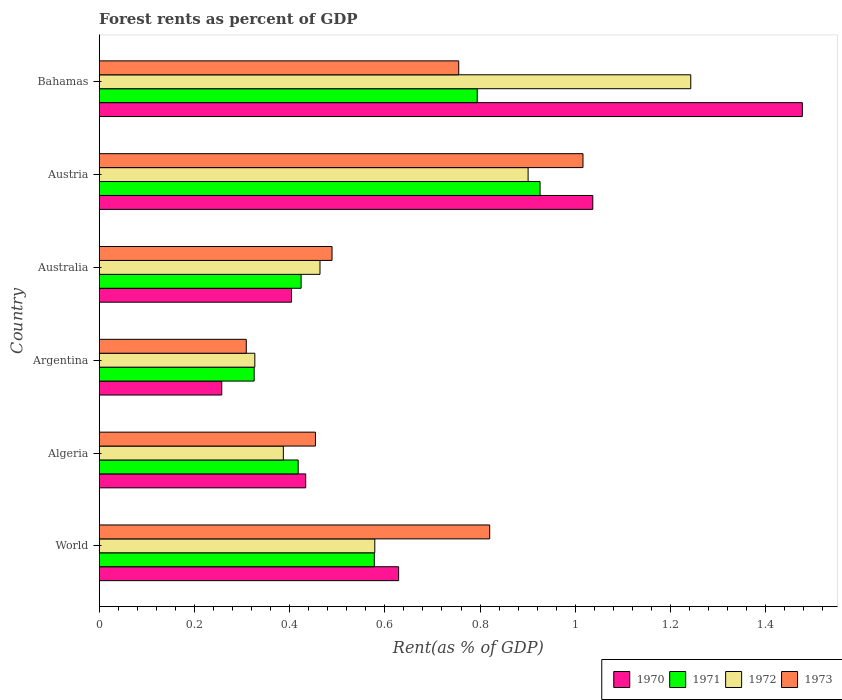How many groups of bars are there?
Keep it short and to the point. 6. Are the number of bars per tick equal to the number of legend labels?
Offer a very short reply. Yes. Are the number of bars on each tick of the Y-axis equal?
Offer a terse response. Yes. What is the label of the 5th group of bars from the top?
Provide a succinct answer. Algeria. In how many cases, is the number of bars for a given country not equal to the number of legend labels?
Offer a terse response. 0. What is the forest rent in 1973 in Bahamas?
Your response must be concise. 0.76. Across all countries, what is the maximum forest rent in 1972?
Make the answer very short. 1.24. Across all countries, what is the minimum forest rent in 1973?
Provide a succinct answer. 0.31. In which country was the forest rent in 1972 maximum?
Provide a short and direct response. Bahamas. What is the total forest rent in 1972 in the graph?
Ensure brevity in your answer.  3.9. What is the difference between the forest rent in 1972 in Australia and that in World?
Ensure brevity in your answer.  -0.12. What is the difference between the forest rent in 1972 in World and the forest rent in 1971 in Algeria?
Offer a terse response. 0.16. What is the average forest rent in 1971 per country?
Offer a terse response. 0.58. What is the difference between the forest rent in 1971 and forest rent in 1970 in Bahamas?
Your response must be concise. -0.68. In how many countries, is the forest rent in 1973 greater than 0.8 %?
Your answer should be compact. 2. What is the ratio of the forest rent in 1971 in Austria to that in Bahamas?
Provide a succinct answer. 1.17. Is the forest rent in 1973 in Argentina less than that in Bahamas?
Provide a succinct answer. Yes. Is the difference between the forest rent in 1971 in Bahamas and World greater than the difference between the forest rent in 1970 in Bahamas and World?
Keep it short and to the point. No. What is the difference between the highest and the second highest forest rent in 1971?
Make the answer very short. 0.13. What is the difference between the highest and the lowest forest rent in 1972?
Your answer should be very brief. 0.92. Is the sum of the forest rent in 1970 in Austria and Bahamas greater than the maximum forest rent in 1972 across all countries?
Give a very brief answer. Yes. Is it the case that in every country, the sum of the forest rent in 1970 and forest rent in 1971 is greater than the sum of forest rent in 1973 and forest rent in 1972?
Provide a succinct answer. No. How many bars are there?
Give a very brief answer. 24. What is the difference between two consecutive major ticks on the X-axis?
Give a very brief answer. 0.2. Are the values on the major ticks of X-axis written in scientific E-notation?
Provide a succinct answer. No. Does the graph contain any zero values?
Make the answer very short. No. Does the graph contain grids?
Offer a very short reply. No. What is the title of the graph?
Give a very brief answer. Forest rents as percent of GDP. Does "1982" appear as one of the legend labels in the graph?
Provide a succinct answer. No. What is the label or title of the X-axis?
Ensure brevity in your answer.  Rent(as % of GDP). What is the Rent(as % of GDP) of 1970 in World?
Your answer should be very brief. 0.63. What is the Rent(as % of GDP) of 1971 in World?
Provide a short and direct response. 0.58. What is the Rent(as % of GDP) of 1972 in World?
Give a very brief answer. 0.58. What is the Rent(as % of GDP) of 1973 in World?
Offer a terse response. 0.82. What is the Rent(as % of GDP) in 1970 in Algeria?
Make the answer very short. 0.43. What is the Rent(as % of GDP) of 1971 in Algeria?
Your answer should be very brief. 0.42. What is the Rent(as % of GDP) in 1972 in Algeria?
Your answer should be very brief. 0.39. What is the Rent(as % of GDP) in 1973 in Algeria?
Offer a terse response. 0.45. What is the Rent(as % of GDP) of 1970 in Argentina?
Provide a succinct answer. 0.26. What is the Rent(as % of GDP) in 1971 in Argentina?
Keep it short and to the point. 0.33. What is the Rent(as % of GDP) of 1972 in Argentina?
Provide a succinct answer. 0.33. What is the Rent(as % of GDP) of 1973 in Argentina?
Keep it short and to the point. 0.31. What is the Rent(as % of GDP) in 1970 in Australia?
Your answer should be very brief. 0.4. What is the Rent(as % of GDP) in 1971 in Australia?
Keep it short and to the point. 0.42. What is the Rent(as % of GDP) in 1972 in Australia?
Ensure brevity in your answer.  0.46. What is the Rent(as % of GDP) of 1973 in Australia?
Provide a short and direct response. 0.49. What is the Rent(as % of GDP) of 1970 in Austria?
Make the answer very short. 1.04. What is the Rent(as % of GDP) of 1971 in Austria?
Give a very brief answer. 0.93. What is the Rent(as % of GDP) in 1972 in Austria?
Give a very brief answer. 0.9. What is the Rent(as % of GDP) in 1973 in Austria?
Provide a succinct answer. 1.02. What is the Rent(as % of GDP) of 1970 in Bahamas?
Provide a short and direct response. 1.48. What is the Rent(as % of GDP) in 1971 in Bahamas?
Make the answer very short. 0.79. What is the Rent(as % of GDP) of 1972 in Bahamas?
Provide a short and direct response. 1.24. What is the Rent(as % of GDP) in 1973 in Bahamas?
Your answer should be very brief. 0.76. Across all countries, what is the maximum Rent(as % of GDP) in 1970?
Provide a short and direct response. 1.48. Across all countries, what is the maximum Rent(as % of GDP) of 1971?
Give a very brief answer. 0.93. Across all countries, what is the maximum Rent(as % of GDP) of 1972?
Your response must be concise. 1.24. Across all countries, what is the maximum Rent(as % of GDP) in 1973?
Provide a succinct answer. 1.02. Across all countries, what is the minimum Rent(as % of GDP) of 1970?
Keep it short and to the point. 0.26. Across all countries, what is the minimum Rent(as % of GDP) in 1971?
Offer a very short reply. 0.33. Across all countries, what is the minimum Rent(as % of GDP) in 1972?
Your response must be concise. 0.33. Across all countries, what is the minimum Rent(as % of GDP) in 1973?
Your response must be concise. 0.31. What is the total Rent(as % of GDP) in 1970 in the graph?
Provide a succinct answer. 4.24. What is the total Rent(as % of GDP) in 1971 in the graph?
Your response must be concise. 3.47. What is the total Rent(as % of GDP) of 1972 in the graph?
Give a very brief answer. 3.9. What is the total Rent(as % of GDP) in 1973 in the graph?
Make the answer very short. 3.84. What is the difference between the Rent(as % of GDP) in 1970 in World and that in Algeria?
Your answer should be compact. 0.2. What is the difference between the Rent(as % of GDP) in 1971 in World and that in Algeria?
Make the answer very short. 0.16. What is the difference between the Rent(as % of GDP) in 1972 in World and that in Algeria?
Your response must be concise. 0.19. What is the difference between the Rent(as % of GDP) in 1973 in World and that in Algeria?
Make the answer very short. 0.37. What is the difference between the Rent(as % of GDP) in 1970 in World and that in Argentina?
Keep it short and to the point. 0.37. What is the difference between the Rent(as % of GDP) in 1971 in World and that in Argentina?
Your answer should be compact. 0.25. What is the difference between the Rent(as % of GDP) in 1972 in World and that in Argentina?
Your answer should be very brief. 0.25. What is the difference between the Rent(as % of GDP) of 1973 in World and that in Argentina?
Offer a terse response. 0.51. What is the difference between the Rent(as % of GDP) in 1970 in World and that in Australia?
Ensure brevity in your answer.  0.23. What is the difference between the Rent(as % of GDP) of 1971 in World and that in Australia?
Offer a terse response. 0.15. What is the difference between the Rent(as % of GDP) of 1972 in World and that in Australia?
Make the answer very short. 0.12. What is the difference between the Rent(as % of GDP) of 1973 in World and that in Australia?
Your answer should be very brief. 0.33. What is the difference between the Rent(as % of GDP) in 1970 in World and that in Austria?
Make the answer very short. -0.41. What is the difference between the Rent(as % of GDP) in 1971 in World and that in Austria?
Provide a short and direct response. -0.35. What is the difference between the Rent(as % of GDP) in 1972 in World and that in Austria?
Provide a short and direct response. -0.32. What is the difference between the Rent(as % of GDP) in 1973 in World and that in Austria?
Ensure brevity in your answer.  -0.2. What is the difference between the Rent(as % of GDP) in 1970 in World and that in Bahamas?
Your response must be concise. -0.85. What is the difference between the Rent(as % of GDP) of 1971 in World and that in Bahamas?
Your answer should be very brief. -0.22. What is the difference between the Rent(as % of GDP) in 1972 in World and that in Bahamas?
Offer a very short reply. -0.66. What is the difference between the Rent(as % of GDP) in 1973 in World and that in Bahamas?
Make the answer very short. 0.07. What is the difference between the Rent(as % of GDP) in 1970 in Algeria and that in Argentina?
Provide a succinct answer. 0.18. What is the difference between the Rent(as % of GDP) in 1971 in Algeria and that in Argentina?
Your answer should be compact. 0.09. What is the difference between the Rent(as % of GDP) in 1972 in Algeria and that in Argentina?
Provide a succinct answer. 0.06. What is the difference between the Rent(as % of GDP) in 1973 in Algeria and that in Argentina?
Provide a succinct answer. 0.15. What is the difference between the Rent(as % of GDP) in 1970 in Algeria and that in Australia?
Give a very brief answer. 0.03. What is the difference between the Rent(as % of GDP) in 1971 in Algeria and that in Australia?
Make the answer very short. -0.01. What is the difference between the Rent(as % of GDP) of 1972 in Algeria and that in Australia?
Provide a succinct answer. -0.08. What is the difference between the Rent(as % of GDP) in 1973 in Algeria and that in Australia?
Your answer should be compact. -0.03. What is the difference between the Rent(as % of GDP) of 1970 in Algeria and that in Austria?
Offer a very short reply. -0.6. What is the difference between the Rent(as % of GDP) of 1971 in Algeria and that in Austria?
Make the answer very short. -0.51. What is the difference between the Rent(as % of GDP) of 1972 in Algeria and that in Austria?
Your answer should be compact. -0.51. What is the difference between the Rent(as % of GDP) of 1973 in Algeria and that in Austria?
Provide a succinct answer. -0.56. What is the difference between the Rent(as % of GDP) of 1970 in Algeria and that in Bahamas?
Provide a succinct answer. -1.04. What is the difference between the Rent(as % of GDP) of 1971 in Algeria and that in Bahamas?
Provide a short and direct response. -0.38. What is the difference between the Rent(as % of GDP) in 1972 in Algeria and that in Bahamas?
Provide a succinct answer. -0.86. What is the difference between the Rent(as % of GDP) in 1973 in Algeria and that in Bahamas?
Offer a very short reply. -0.3. What is the difference between the Rent(as % of GDP) of 1970 in Argentina and that in Australia?
Your answer should be compact. -0.15. What is the difference between the Rent(as % of GDP) in 1971 in Argentina and that in Australia?
Keep it short and to the point. -0.1. What is the difference between the Rent(as % of GDP) in 1972 in Argentina and that in Australia?
Give a very brief answer. -0.14. What is the difference between the Rent(as % of GDP) of 1973 in Argentina and that in Australia?
Your answer should be compact. -0.18. What is the difference between the Rent(as % of GDP) in 1970 in Argentina and that in Austria?
Offer a terse response. -0.78. What is the difference between the Rent(as % of GDP) in 1971 in Argentina and that in Austria?
Provide a succinct answer. -0.6. What is the difference between the Rent(as % of GDP) of 1972 in Argentina and that in Austria?
Ensure brevity in your answer.  -0.57. What is the difference between the Rent(as % of GDP) in 1973 in Argentina and that in Austria?
Make the answer very short. -0.71. What is the difference between the Rent(as % of GDP) in 1970 in Argentina and that in Bahamas?
Provide a short and direct response. -1.22. What is the difference between the Rent(as % of GDP) of 1971 in Argentina and that in Bahamas?
Provide a succinct answer. -0.47. What is the difference between the Rent(as % of GDP) of 1972 in Argentina and that in Bahamas?
Your answer should be compact. -0.92. What is the difference between the Rent(as % of GDP) of 1973 in Argentina and that in Bahamas?
Make the answer very short. -0.45. What is the difference between the Rent(as % of GDP) in 1970 in Australia and that in Austria?
Give a very brief answer. -0.63. What is the difference between the Rent(as % of GDP) of 1971 in Australia and that in Austria?
Ensure brevity in your answer.  -0.5. What is the difference between the Rent(as % of GDP) of 1972 in Australia and that in Austria?
Your answer should be compact. -0.44. What is the difference between the Rent(as % of GDP) of 1973 in Australia and that in Austria?
Provide a succinct answer. -0.53. What is the difference between the Rent(as % of GDP) in 1970 in Australia and that in Bahamas?
Ensure brevity in your answer.  -1.07. What is the difference between the Rent(as % of GDP) of 1971 in Australia and that in Bahamas?
Make the answer very short. -0.37. What is the difference between the Rent(as % of GDP) of 1972 in Australia and that in Bahamas?
Provide a short and direct response. -0.78. What is the difference between the Rent(as % of GDP) of 1973 in Australia and that in Bahamas?
Provide a short and direct response. -0.27. What is the difference between the Rent(as % of GDP) in 1970 in Austria and that in Bahamas?
Your response must be concise. -0.44. What is the difference between the Rent(as % of GDP) of 1971 in Austria and that in Bahamas?
Provide a succinct answer. 0.13. What is the difference between the Rent(as % of GDP) in 1972 in Austria and that in Bahamas?
Your answer should be very brief. -0.34. What is the difference between the Rent(as % of GDP) in 1973 in Austria and that in Bahamas?
Offer a very short reply. 0.26. What is the difference between the Rent(as % of GDP) in 1970 in World and the Rent(as % of GDP) in 1971 in Algeria?
Offer a terse response. 0.21. What is the difference between the Rent(as % of GDP) of 1970 in World and the Rent(as % of GDP) of 1972 in Algeria?
Provide a succinct answer. 0.24. What is the difference between the Rent(as % of GDP) of 1970 in World and the Rent(as % of GDP) of 1973 in Algeria?
Give a very brief answer. 0.17. What is the difference between the Rent(as % of GDP) of 1971 in World and the Rent(as % of GDP) of 1972 in Algeria?
Provide a short and direct response. 0.19. What is the difference between the Rent(as % of GDP) in 1971 in World and the Rent(as % of GDP) in 1973 in Algeria?
Your answer should be very brief. 0.12. What is the difference between the Rent(as % of GDP) in 1972 in World and the Rent(as % of GDP) in 1973 in Algeria?
Keep it short and to the point. 0.12. What is the difference between the Rent(as % of GDP) of 1970 in World and the Rent(as % of GDP) of 1971 in Argentina?
Your response must be concise. 0.3. What is the difference between the Rent(as % of GDP) of 1970 in World and the Rent(as % of GDP) of 1972 in Argentina?
Provide a short and direct response. 0.3. What is the difference between the Rent(as % of GDP) of 1970 in World and the Rent(as % of GDP) of 1973 in Argentina?
Your answer should be very brief. 0.32. What is the difference between the Rent(as % of GDP) in 1971 in World and the Rent(as % of GDP) in 1972 in Argentina?
Offer a terse response. 0.25. What is the difference between the Rent(as % of GDP) of 1971 in World and the Rent(as % of GDP) of 1973 in Argentina?
Give a very brief answer. 0.27. What is the difference between the Rent(as % of GDP) in 1972 in World and the Rent(as % of GDP) in 1973 in Argentina?
Your answer should be very brief. 0.27. What is the difference between the Rent(as % of GDP) of 1970 in World and the Rent(as % of GDP) of 1971 in Australia?
Your answer should be compact. 0.2. What is the difference between the Rent(as % of GDP) of 1970 in World and the Rent(as % of GDP) of 1972 in Australia?
Provide a short and direct response. 0.17. What is the difference between the Rent(as % of GDP) in 1970 in World and the Rent(as % of GDP) in 1973 in Australia?
Your response must be concise. 0.14. What is the difference between the Rent(as % of GDP) in 1971 in World and the Rent(as % of GDP) in 1972 in Australia?
Your answer should be compact. 0.11. What is the difference between the Rent(as % of GDP) in 1971 in World and the Rent(as % of GDP) in 1973 in Australia?
Offer a terse response. 0.09. What is the difference between the Rent(as % of GDP) in 1972 in World and the Rent(as % of GDP) in 1973 in Australia?
Provide a succinct answer. 0.09. What is the difference between the Rent(as % of GDP) of 1970 in World and the Rent(as % of GDP) of 1971 in Austria?
Keep it short and to the point. -0.3. What is the difference between the Rent(as % of GDP) in 1970 in World and the Rent(as % of GDP) in 1972 in Austria?
Offer a terse response. -0.27. What is the difference between the Rent(as % of GDP) in 1970 in World and the Rent(as % of GDP) in 1973 in Austria?
Your response must be concise. -0.39. What is the difference between the Rent(as % of GDP) of 1971 in World and the Rent(as % of GDP) of 1972 in Austria?
Provide a succinct answer. -0.32. What is the difference between the Rent(as % of GDP) of 1971 in World and the Rent(as % of GDP) of 1973 in Austria?
Your answer should be compact. -0.44. What is the difference between the Rent(as % of GDP) of 1972 in World and the Rent(as % of GDP) of 1973 in Austria?
Keep it short and to the point. -0.44. What is the difference between the Rent(as % of GDP) of 1970 in World and the Rent(as % of GDP) of 1971 in Bahamas?
Make the answer very short. -0.17. What is the difference between the Rent(as % of GDP) of 1970 in World and the Rent(as % of GDP) of 1972 in Bahamas?
Ensure brevity in your answer.  -0.61. What is the difference between the Rent(as % of GDP) in 1970 in World and the Rent(as % of GDP) in 1973 in Bahamas?
Offer a terse response. -0.13. What is the difference between the Rent(as % of GDP) of 1971 in World and the Rent(as % of GDP) of 1972 in Bahamas?
Give a very brief answer. -0.66. What is the difference between the Rent(as % of GDP) of 1971 in World and the Rent(as % of GDP) of 1973 in Bahamas?
Provide a succinct answer. -0.18. What is the difference between the Rent(as % of GDP) in 1972 in World and the Rent(as % of GDP) in 1973 in Bahamas?
Your response must be concise. -0.18. What is the difference between the Rent(as % of GDP) of 1970 in Algeria and the Rent(as % of GDP) of 1971 in Argentina?
Keep it short and to the point. 0.11. What is the difference between the Rent(as % of GDP) of 1970 in Algeria and the Rent(as % of GDP) of 1972 in Argentina?
Provide a short and direct response. 0.11. What is the difference between the Rent(as % of GDP) in 1970 in Algeria and the Rent(as % of GDP) in 1973 in Argentina?
Your response must be concise. 0.12. What is the difference between the Rent(as % of GDP) of 1971 in Algeria and the Rent(as % of GDP) of 1972 in Argentina?
Make the answer very short. 0.09. What is the difference between the Rent(as % of GDP) in 1971 in Algeria and the Rent(as % of GDP) in 1973 in Argentina?
Provide a succinct answer. 0.11. What is the difference between the Rent(as % of GDP) of 1972 in Algeria and the Rent(as % of GDP) of 1973 in Argentina?
Offer a terse response. 0.08. What is the difference between the Rent(as % of GDP) in 1970 in Algeria and the Rent(as % of GDP) in 1971 in Australia?
Offer a terse response. 0.01. What is the difference between the Rent(as % of GDP) of 1970 in Algeria and the Rent(as % of GDP) of 1972 in Australia?
Ensure brevity in your answer.  -0.03. What is the difference between the Rent(as % of GDP) in 1970 in Algeria and the Rent(as % of GDP) in 1973 in Australia?
Provide a short and direct response. -0.06. What is the difference between the Rent(as % of GDP) of 1971 in Algeria and the Rent(as % of GDP) of 1972 in Australia?
Ensure brevity in your answer.  -0.05. What is the difference between the Rent(as % of GDP) in 1971 in Algeria and the Rent(as % of GDP) in 1973 in Australia?
Offer a terse response. -0.07. What is the difference between the Rent(as % of GDP) of 1972 in Algeria and the Rent(as % of GDP) of 1973 in Australia?
Ensure brevity in your answer.  -0.1. What is the difference between the Rent(as % of GDP) of 1970 in Algeria and the Rent(as % of GDP) of 1971 in Austria?
Make the answer very short. -0.49. What is the difference between the Rent(as % of GDP) in 1970 in Algeria and the Rent(as % of GDP) in 1972 in Austria?
Give a very brief answer. -0.47. What is the difference between the Rent(as % of GDP) of 1970 in Algeria and the Rent(as % of GDP) of 1973 in Austria?
Your answer should be very brief. -0.58. What is the difference between the Rent(as % of GDP) of 1971 in Algeria and the Rent(as % of GDP) of 1972 in Austria?
Your answer should be very brief. -0.48. What is the difference between the Rent(as % of GDP) in 1971 in Algeria and the Rent(as % of GDP) in 1973 in Austria?
Provide a short and direct response. -0.6. What is the difference between the Rent(as % of GDP) of 1972 in Algeria and the Rent(as % of GDP) of 1973 in Austria?
Provide a short and direct response. -0.63. What is the difference between the Rent(as % of GDP) in 1970 in Algeria and the Rent(as % of GDP) in 1971 in Bahamas?
Ensure brevity in your answer.  -0.36. What is the difference between the Rent(as % of GDP) in 1970 in Algeria and the Rent(as % of GDP) in 1972 in Bahamas?
Your answer should be compact. -0.81. What is the difference between the Rent(as % of GDP) in 1970 in Algeria and the Rent(as % of GDP) in 1973 in Bahamas?
Your answer should be very brief. -0.32. What is the difference between the Rent(as % of GDP) in 1971 in Algeria and the Rent(as % of GDP) in 1972 in Bahamas?
Give a very brief answer. -0.82. What is the difference between the Rent(as % of GDP) of 1971 in Algeria and the Rent(as % of GDP) of 1973 in Bahamas?
Offer a very short reply. -0.34. What is the difference between the Rent(as % of GDP) in 1972 in Algeria and the Rent(as % of GDP) in 1973 in Bahamas?
Give a very brief answer. -0.37. What is the difference between the Rent(as % of GDP) of 1970 in Argentina and the Rent(as % of GDP) of 1972 in Australia?
Make the answer very short. -0.21. What is the difference between the Rent(as % of GDP) of 1970 in Argentina and the Rent(as % of GDP) of 1973 in Australia?
Give a very brief answer. -0.23. What is the difference between the Rent(as % of GDP) in 1971 in Argentina and the Rent(as % of GDP) in 1972 in Australia?
Your answer should be very brief. -0.14. What is the difference between the Rent(as % of GDP) of 1971 in Argentina and the Rent(as % of GDP) of 1973 in Australia?
Ensure brevity in your answer.  -0.16. What is the difference between the Rent(as % of GDP) of 1972 in Argentina and the Rent(as % of GDP) of 1973 in Australia?
Your answer should be compact. -0.16. What is the difference between the Rent(as % of GDP) of 1970 in Argentina and the Rent(as % of GDP) of 1971 in Austria?
Your answer should be compact. -0.67. What is the difference between the Rent(as % of GDP) of 1970 in Argentina and the Rent(as % of GDP) of 1972 in Austria?
Keep it short and to the point. -0.64. What is the difference between the Rent(as % of GDP) of 1970 in Argentina and the Rent(as % of GDP) of 1973 in Austria?
Provide a succinct answer. -0.76. What is the difference between the Rent(as % of GDP) in 1971 in Argentina and the Rent(as % of GDP) in 1972 in Austria?
Ensure brevity in your answer.  -0.58. What is the difference between the Rent(as % of GDP) in 1971 in Argentina and the Rent(as % of GDP) in 1973 in Austria?
Offer a very short reply. -0.69. What is the difference between the Rent(as % of GDP) in 1972 in Argentina and the Rent(as % of GDP) in 1973 in Austria?
Give a very brief answer. -0.69. What is the difference between the Rent(as % of GDP) in 1970 in Argentina and the Rent(as % of GDP) in 1971 in Bahamas?
Provide a short and direct response. -0.54. What is the difference between the Rent(as % of GDP) of 1970 in Argentina and the Rent(as % of GDP) of 1972 in Bahamas?
Offer a very short reply. -0.99. What is the difference between the Rent(as % of GDP) in 1970 in Argentina and the Rent(as % of GDP) in 1973 in Bahamas?
Keep it short and to the point. -0.5. What is the difference between the Rent(as % of GDP) in 1971 in Argentina and the Rent(as % of GDP) in 1972 in Bahamas?
Your answer should be very brief. -0.92. What is the difference between the Rent(as % of GDP) in 1971 in Argentina and the Rent(as % of GDP) in 1973 in Bahamas?
Keep it short and to the point. -0.43. What is the difference between the Rent(as % of GDP) in 1972 in Argentina and the Rent(as % of GDP) in 1973 in Bahamas?
Offer a very short reply. -0.43. What is the difference between the Rent(as % of GDP) in 1970 in Australia and the Rent(as % of GDP) in 1971 in Austria?
Give a very brief answer. -0.52. What is the difference between the Rent(as % of GDP) of 1970 in Australia and the Rent(as % of GDP) of 1972 in Austria?
Make the answer very short. -0.5. What is the difference between the Rent(as % of GDP) in 1970 in Australia and the Rent(as % of GDP) in 1973 in Austria?
Offer a very short reply. -0.61. What is the difference between the Rent(as % of GDP) in 1971 in Australia and the Rent(as % of GDP) in 1972 in Austria?
Provide a short and direct response. -0.48. What is the difference between the Rent(as % of GDP) of 1971 in Australia and the Rent(as % of GDP) of 1973 in Austria?
Your answer should be very brief. -0.59. What is the difference between the Rent(as % of GDP) in 1972 in Australia and the Rent(as % of GDP) in 1973 in Austria?
Keep it short and to the point. -0.55. What is the difference between the Rent(as % of GDP) of 1970 in Australia and the Rent(as % of GDP) of 1971 in Bahamas?
Your answer should be compact. -0.39. What is the difference between the Rent(as % of GDP) of 1970 in Australia and the Rent(as % of GDP) of 1972 in Bahamas?
Make the answer very short. -0.84. What is the difference between the Rent(as % of GDP) of 1970 in Australia and the Rent(as % of GDP) of 1973 in Bahamas?
Your answer should be compact. -0.35. What is the difference between the Rent(as % of GDP) of 1971 in Australia and the Rent(as % of GDP) of 1972 in Bahamas?
Give a very brief answer. -0.82. What is the difference between the Rent(as % of GDP) of 1971 in Australia and the Rent(as % of GDP) of 1973 in Bahamas?
Your response must be concise. -0.33. What is the difference between the Rent(as % of GDP) of 1972 in Australia and the Rent(as % of GDP) of 1973 in Bahamas?
Provide a succinct answer. -0.29. What is the difference between the Rent(as % of GDP) of 1970 in Austria and the Rent(as % of GDP) of 1971 in Bahamas?
Make the answer very short. 0.24. What is the difference between the Rent(as % of GDP) of 1970 in Austria and the Rent(as % of GDP) of 1972 in Bahamas?
Offer a terse response. -0.21. What is the difference between the Rent(as % of GDP) of 1970 in Austria and the Rent(as % of GDP) of 1973 in Bahamas?
Your response must be concise. 0.28. What is the difference between the Rent(as % of GDP) in 1971 in Austria and the Rent(as % of GDP) in 1972 in Bahamas?
Give a very brief answer. -0.32. What is the difference between the Rent(as % of GDP) of 1971 in Austria and the Rent(as % of GDP) of 1973 in Bahamas?
Make the answer very short. 0.17. What is the difference between the Rent(as % of GDP) of 1972 in Austria and the Rent(as % of GDP) of 1973 in Bahamas?
Your answer should be compact. 0.15. What is the average Rent(as % of GDP) in 1970 per country?
Ensure brevity in your answer.  0.71. What is the average Rent(as % of GDP) in 1971 per country?
Give a very brief answer. 0.58. What is the average Rent(as % of GDP) in 1972 per country?
Offer a very short reply. 0.65. What is the average Rent(as % of GDP) of 1973 per country?
Your response must be concise. 0.64. What is the difference between the Rent(as % of GDP) of 1970 and Rent(as % of GDP) of 1971 in World?
Offer a terse response. 0.05. What is the difference between the Rent(as % of GDP) of 1970 and Rent(as % of GDP) of 1972 in World?
Ensure brevity in your answer.  0.05. What is the difference between the Rent(as % of GDP) of 1970 and Rent(as % of GDP) of 1973 in World?
Offer a very short reply. -0.19. What is the difference between the Rent(as % of GDP) in 1971 and Rent(as % of GDP) in 1972 in World?
Your answer should be very brief. -0. What is the difference between the Rent(as % of GDP) of 1971 and Rent(as % of GDP) of 1973 in World?
Offer a very short reply. -0.24. What is the difference between the Rent(as % of GDP) in 1972 and Rent(as % of GDP) in 1973 in World?
Offer a terse response. -0.24. What is the difference between the Rent(as % of GDP) in 1970 and Rent(as % of GDP) in 1971 in Algeria?
Your answer should be very brief. 0.02. What is the difference between the Rent(as % of GDP) in 1970 and Rent(as % of GDP) in 1972 in Algeria?
Offer a very short reply. 0.05. What is the difference between the Rent(as % of GDP) of 1970 and Rent(as % of GDP) of 1973 in Algeria?
Offer a very short reply. -0.02. What is the difference between the Rent(as % of GDP) in 1971 and Rent(as % of GDP) in 1972 in Algeria?
Make the answer very short. 0.03. What is the difference between the Rent(as % of GDP) in 1971 and Rent(as % of GDP) in 1973 in Algeria?
Provide a short and direct response. -0.04. What is the difference between the Rent(as % of GDP) in 1972 and Rent(as % of GDP) in 1973 in Algeria?
Provide a short and direct response. -0.07. What is the difference between the Rent(as % of GDP) of 1970 and Rent(as % of GDP) of 1971 in Argentina?
Your response must be concise. -0.07. What is the difference between the Rent(as % of GDP) of 1970 and Rent(as % of GDP) of 1972 in Argentina?
Your answer should be very brief. -0.07. What is the difference between the Rent(as % of GDP) of 1970 and Rent(as % of GDP) of 1973 in Argentina?
Offer a terse response. -0.05. What is the difference between the Rent(as % of GDP) in 1971 and Rent(as % of GDP) in 1972 in Argentina?
Your answer should be compact. -0. What is the difference between the Rent(as % of GDP) of 1971 and Rent(as % of GDP) of 1973 in Argentina?
Offer a very short reply. 0.02. What is the difference between the Rent(as % of GDP) of 1972 and Rent(as % of GDP) of 1973 in Argentina?
Offer a terse response. 0.02. What is the difference between the Rent(as % of GDP) in 1970 and Rent(as % of GDP) in 1971 in Australia?
Provide a short and direct response. -0.02. What is the difference between the Rent(as % of GDP) of 1970 and Rent(as % of GDP) of 1972 in Australia?
Give a very brief answer. -0.06. What is the difference between the Rent(as % of GDP) of 1970 and Rent(as % of GDP) of 1973 in Australia?
Ensure brevity in your answer.  -0.09. What is the difference between the Rent(as % of GDP) of 1971 and Rent(as % of GDP) of 1972 in Australia?
Keep it short and to the point. -0.04. What is the difference between the Rent(as % of GDP) of 1971 and Rent(as % of GDP) of 1973 in Australia?
Give a very brief answer. -0.06. What is the difference between the Rent(as % of GDP) of 1972 and Rent(as % of GDP) of 1973 in Australia?
Ensure brevity in your answer.  -0.03. What is the difference between the Rent(as % of GDP) of 1970 and Rent(as % of GDP) of 1971 in Austria?
Your answer should be very brief. 0.11. What is the difference between the Rent(as % of GDP) in 1970 and Rent(as % of GDP) in 1972 in Austria?
Ensure brevity in your answer.  0.14. What is the difference between the Rent(as % of GDP) of 1970 and Rent(as % of GDP) of 1973 in Austria?
Offer a terse response. 0.02. What is the difference between the Rent(as % of GDP) in 1971 and Rent(as % of GDP) in 1972 in Austria?
Your answer should be compact. 0.03. What is the difference between the Rent(as % of GDP) of 1971 and Rent(as % of GDP) of 1973 in Austria?
Make the answer very short. -0.09. What is the difference between the Rent(as % of GDP) of 1972 and Rent(as % of GDP) of 1973 in Austria?
Make the answer very short. -0.12. What is the difference between the Rent(as % of GDP) of 1970 and Rent(as % of GDP) of 1971 in Bahamas?
Give a very brief answer. 0.68. What is the difference between the Rent(as % of GDP) of 1970 and Rent(as % of GDP) of 1972 in Bahamas?
Your answer should be very brief. 0.23. What is the difference between the Rent(as % of GDP) in 1970 and Rent(as % of GDP) in 1973 in Bahamas?
Offer a terse response. 0.72. What is the difference between the Rent(as % of GDP) of 1971 and Rent(as % of GDP) of 1972 in Bahamas?
Your response must be concise. -0.45. What is the difference between the Rent(as % of GDP) of 1971 and Rent(as % of GDP) of 1973 in Bahamas?
Ensure brevity in your answer.  0.04. What is the difference between the Rent(as % of GDP) in 1972 and Rent(as % of GDP) in 1973 in Bahamas?
Your answer should be very brief. 0.49. What is the ratio of the Rent(as % of GDP) of 1970 in World to that in Algeria?
Make the answer very short. 1.45. What is the ratio of the Rent(as % of GDP) in 1971 in World to that in Algeria?
Provide a succinct answer. 1.38. What is the ratio of the Rent(as % of GDP) in 1972 in World to that in Algeria?
Your answer should be compact. 1.5. What is the ratio of the Rent(as % of GDP) in 1973 in World to that in Algeria?
Give a very brief answer. 1.81. What is the ratio of the Rent(as % of GDP) of 1970 in World to that in Argentina?
Make the answer very short. 2.44. What is the ratio of the Rent(as % of GDP) of 1971 in World to that in Argentina?
Offer a very short reply. 1.78. What is the ratio of the Rent(as % of GDP) of 1972 in World to that in Argentina?
Your answer should be very brief. 1.77. What is the ratio of the Rent(as % of GDP) in 1973 in World to that in Argentina?
Your answer should be very brief. 2.66. What is the ratio of the Rent(as % of GDP) of 1970 in World to that in Australia?
Your answer should be very brief. 1.56. What is the ratio of the Rent(as % of GDP) of 1971 in World to that in Australia?
Your answer should be very brief. 1.36. What is the ratio of the Rent(as % of GDP) of 1972 in World to that in Australia?
Your response must be concise. 1.25. What is the ratio of the Rent(as % of GDP) in 1973 in World to that in Australia?
Provide a succinct answer. 1.68. What is the ratio of the Rent(as % of GDP) in 1970 in World to that in Austria?
Offer a terse response. 0.61. What is the ratio of the Rent(as % of GDP) in 1971 in World to that in Austria?
Give a very brief answer. 0.62. What is the ratio of the Rent(as % of GDP) of 1972 in World to that in Austria?
Offer a terse response. 0.64. What is the ratio of the Rent(as % of GDP) of 1973 in World to that in Austria?
Your answer should be compact. 0.81. What is the ratio of the Rent(as % of GDP) in 1970 in World to that in Bahamas?
Give a very brief answer. 0.43. What is the ratio of the Rent(as % of GDP) in 1971 in World to that in Bahamas?
Give a very brief answer. 0.73. What is the ratio of the Rent(as % of GDP) in 1972 in World to that in Bahamas?
Keep it short and to the point. 0.47. What is the ratio of the Rent(as % of GDP) in 1973 in World to that in Bahamas?
Offer a terse response. 1.09. What is the ratio of the Rent(as % of GDP) in 1970 in Algeria to that in Argentina?
Ensure brevity in your answer.  1.69. What is the ratio of the Rent(as % of GDP) in 1971 in Algeria to that in Argentina?
Your answer should be very brief. 1.28. What is the ratio of the Rent(as % of GDP) in 1972 in Algeria to that in Argentina?
Your response must be concise. 1.18. What is the ratio of the Rent(as % of GDP) in 1973 in Algeria to that in Argentina?
Offer a terse response. 1.47. What is the ratio of the Rent(as % of GDP) of 1970 in Algeria to that in Australia?
Provide a short and direct response. 1.07. What is the ratio of the Rent(as % of GDP) of 1971 in Algeria to that in Australia?
Give a very brief answer. 0.99. What is the ratio of the Rent(as % of GDP) of 1972 in Algeria to that in Australia?
Offer a very short reply. 0.83. What is the ratio of the Rent(as % of GDP) in 1973 in Algeria to that in Australia?
Ensure brevity in your answer.  0.93. What is the ratio of the Rent(as % of GDP) in 1970 in Algeria to that in Austria?
Make the answer very short. 0.42. What is the ratio of the Rent(as % of GDP) of 1971 in Algeria to that in Austria?
Keep it short and to the point. 0.45. What is the ratio of the Rent(as % of GDP) of 1972 in Algeria to that in Austria?
Ensure brevity in your answer.  0.43. What is the ratio of the Rent(as % of GDP) in 1973 in Algeria to that in Austria?
Make the answer very short. 0.45. What is the ratio of the Rent(as % of GDP) of 1970 in Algeria to that in Bahamas?
Offer a very short reply. 0.29. What is the ratio of the Rent(as % of GDP) of 1971 in Algeria to that in Bahamas?
Keep it short and to the point. 0.53. What is the ratio of the Rent(as % of GDP) in 1972 in Algeria to that in Bahamas?
Provide a short and direct response. 0.31. What is the ratio of the Rent(as % of GDP) of 1973 in Algeria to that in Bahamas?
Provide a short and direct response. 0.6. What is the ratio of the Rent(as % of GDP) in 1970 in Argentina to that in Australia?
Provide a short and direct response. 0.64. What is the ratio of the Rent(as % of GDP) in 1971 in Argentina to that in Australia?
Make the answer very short. 0.77. What is the ratio of the Rent(as % of GDP) in 1972 in Argentina to that in Australia?
Your answer should be very brief. 0.7. What is the ratio of the Rent(as % of GDP) of 1973 in Argentina to that in Australia?
Offer a very short reply. 0.63. What is the ratio of the Rent(as % of GDP) in 1970 in Argentina to that in Austria?
Offer a terse response. 0.25. What is the ratio of the Rent(as % of GDP) in 1971 in Argentina to that in Austria?
Keep it short and to the point. 0.35. What is the ratio of the Rent(as % of GDP) of 1972 in Argentina to that in Austria?
Your answer should be very brief. 0.36. What is the ratio of the Rent(as % of GDP) in 1973 in Argentina to that in Austria?
Ensure brevity in your answer.  0.3. What is the ratio of the Rent(as % of GDP) of 1970 in Argentina to that in Bahamas?
Ensure brevity in your answer.  0.17. What is the ratio of the Rent(as % of GDP) of 1971 in Argentina to that in Bahamas?
Offer a terse response. 0.41. What is the ratio of the Rent(as % of GDP) of 1972 in Argentina to that in Bahamas?
Offer a very short reply. 0.26. What is the ratio of the Rent(as % of GDP) of 1973 in Argentina to that in Bahamas?
Your answer should be very brief. 0.41. What is the ratio of the Rent(as % of GDP) of 1970 in Australia to that in Austria?
Offer a terse response. 0.39. What is the ratio of the Rent(as % of GDP) in 1971 in Australia to that in Austria?
Provide a succinct answer. 0.46. What is the ratio of the Rent(as % of GDP) of 1972 in Australia to that in Austria?
Your answer should be compact. 0.51. What is the ratio of the Rent(as % of GDP) of 1973 in Australia to that in Austria?
Your answer should be very brief. 0.48. What is the ratio of the Rent(as % of GDP) in 1970 in Australia to that in Bahamas?
Make the answer very short. 0.27. What is the ratio of the Rent(as % of GDP) of 1971 in Australia to that in Bahamas?
Your response must be concise. 0.53. What is the ratio of the Rent(as % of GDP) of 1972 in Australia to that in Bahamas?
Give a very brief answer. 0.37. What is the ratio of the Rent(as % of GDP) in 1973 in Australia to that in Bahamas?
Your answer should be very brief. 0.65. What is the ratio of the Rent(as % of GDP) of 1970 in Austria to that in Bahamas?
Give a very brief answer. 0.7. What is the ratio of the Rent(as % of GDP) in 1971 in Austria to that in Bahamas?
Your response must be concise. 1.17. What is the ratio of the Rent(as % of GDP) of 1972 in Austria to that in Bahamas?
Keep it short and to the point. 0.72. What is the ratio of the Rent(as % of GDP) of 1973 in Austria to that in Bahamas?
Give a very brief answer. 1.35. What is the difference between the highest and the second highest Rent(as % of GDP) of 1970?
Offer a terse response. 0.44. What is the difference between the highest and the second highest Rent(as % of GDP) of 1971?
Your response must be concise. 0.13. What is the difference between the highest and the second highest Rent(as % of GDP) in 1972?
Your response must be concise. 0.34. What is the difference between the highest and the second highest Rent(as % of GDP) in 1973?
Your answer should be very brief. 0.2. What is the difference between the highest and the lowest Rent(as % of GDP) of 1970?
Make the answer very short. 1.22. What is the difference between the highest and the lowest Rent(as % of GDP) of 1971?
Provide a short and direct response. 0.6. What is the difference between the highest and the lowest Rent(as % of GDP) in 1972?
Your answer should be very brief. 0.92. What is the difference between the highest and the lowest Rent(as % of GDP) in 1973?
Provide a short and direct response. 0.71. 